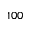<formula> <loc_0><loc_0><loc_500><loc_500>1 0 0</formula> 